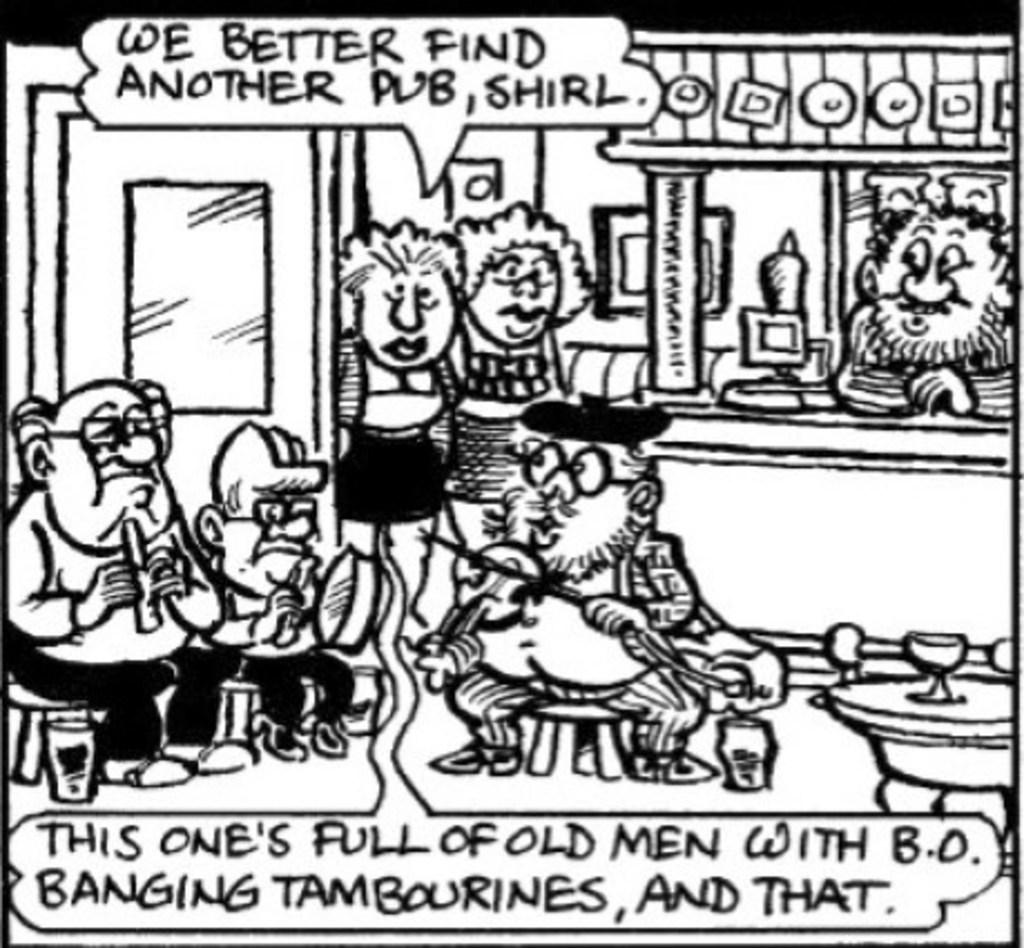What style is the image in? The image appears to be a drawing. What type of images are included in the drawing? The drawing contains cartoon images. Are there any words or letters on the drawing? Yes, there are letters on the drawing. What kind of characters are depicted in the drawing? The drawing includes people. What architectural feature is shown in the drawing? There is a door depicted in the drawing. What type of furniture is present in the drawing? A table is present in the drawing. What object related to drinking is visible in the drawing? A glass is visible in the drawing. Can you tell me how many holes are in the drawing? There is no mention of any holes in the drawing, so it is not possible to determine their number. Is the person in the drawing related to the viewer as an aunt? There is no information about the relationship between the person in the drawing and the viewer, so it cannot be determined if they are an aunt. 